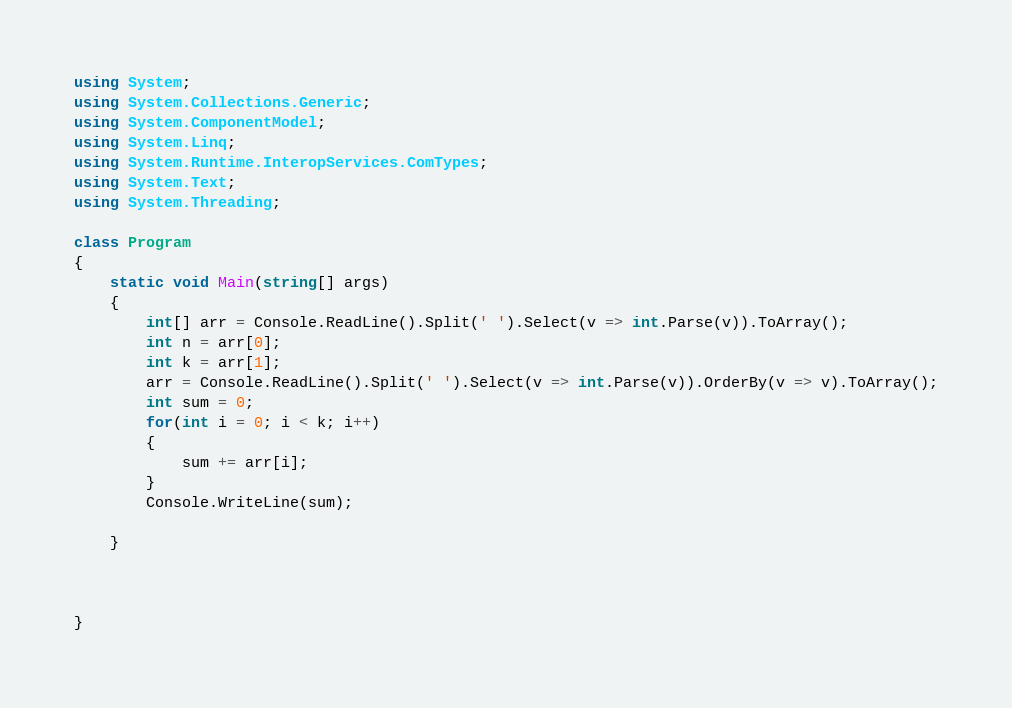Convert code to text. <code><loc_0><loc_0><loc_500><loc_500><_C#_>using System;
using System.Collections.Generic;
using System.ComponentModel;
using System.Linq;
using System.Runtime.InteropServices.ComTypes;
using System.Text;
using System.Threading;

class Program
{
    static void Main(string[] args)
    {
        int[] arr = Console.ReadLine().Split(' ').Select(v => int.Parse(v)).ToArray();
        int n = arr[0];
        int k = arr[1];
        arr = Console.ReadLine().Split(' ').Select(v => int.Parse(v)).OrderBy(v => v).ToArray();
        int sum = 0;
        for(int i = 0; i < k; i++)
        {
            sum += arr[i];
        }
        Console.WriteLine(sum);

    }

    

}</code> 